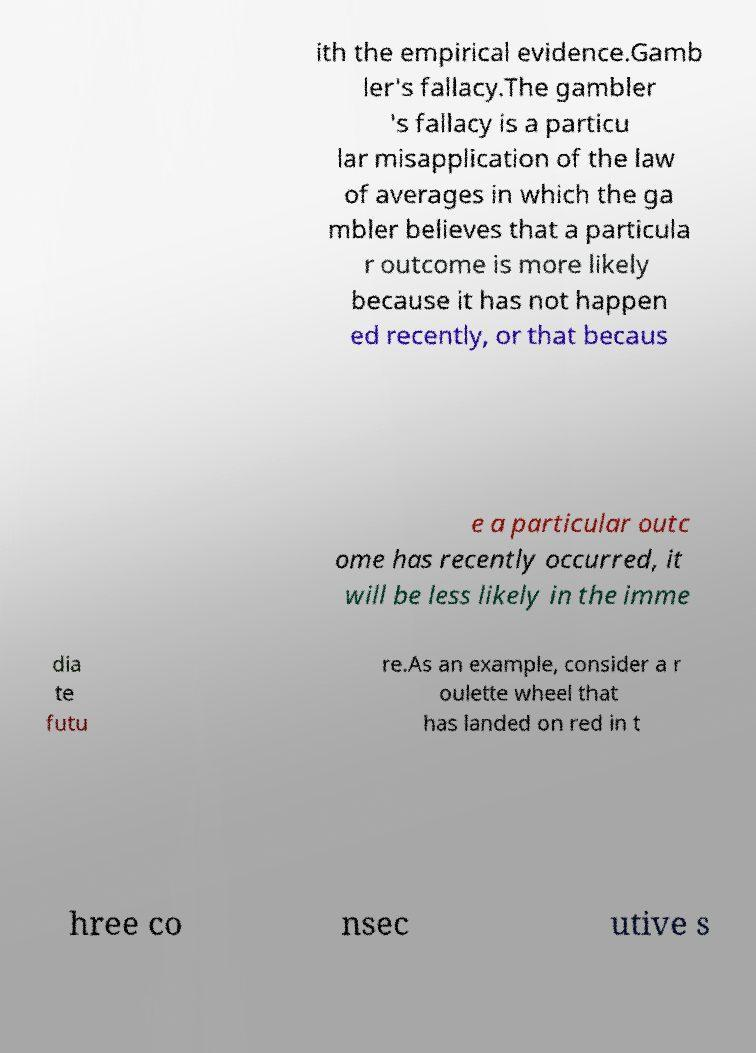Please read and relay the text visible in this image. What does it say? ith the empirical evidence.Gamb ler's fallacy.The gambler 's fallacy is a particu lar misapplication of the law of averages in which the ga mbler believes that a particula r outcome is more likely because it has not happen ed recently, or that becaus e a particular outc ome has recently occurred, it will be less likely in the imme dia te futu re.As an example, consider a r oulette wheel that has landed on red in t hree co nsec utive s 